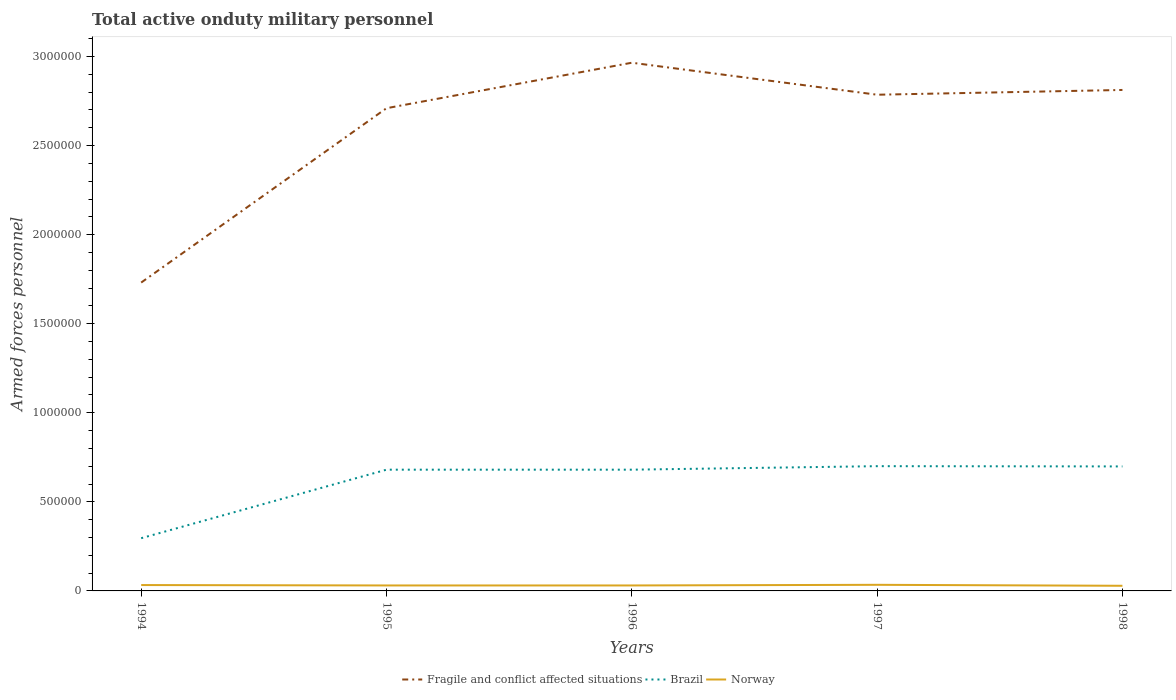Does the line corresponding to Brazil intersect with the line corresponding to Fragile and conflict affected situations?
Make the answer very short. No. Is the number of lines equal to the number of legend labels?
Ensure brevity in your answer.  Yes. Across all years, what is the maximum number of armed forces personnel in Brazil?
Ensure brevity in your answer.  2.96e+05. In which year was the number of armed forces personnel in Fragile and conflict affected situations maximum?
Your answer should be compact. 1994. What is the total number of armed forces personnel in Brazil in the graph?
Your answer should be very brief. -1.82e+04. What is the difference between the highest and the second highest number of armed forces personnel in Brazil?
Keep it short and to the point. 4.04e+05. Is the number of armed forces personnel in Brazil strictly greater than the number of armed forces personnel in Fragile and conflict affected situations over the years?
Ensure brevity in your answer.  Yes. How many lines are there?
Your answer should be very brief. 3. Are the values on the major ticks of Y-axis written in scientific E-notation?
Ensure brevity in your answer.  No. Does the graph contain any zero values?
Provide a succinct answer. No. Does the graph contain grids?
Offer a terse response. No. Where does the legend appear in the graph?
Your answer should be compact. Bottom center. What is the title of the graph?
Ensure brevity in your answer.  Total active onduty military personnel. What is the label or title of the Y-axis?
Your answer should be very brief. Armed forces personnel. What is the Armed forces personnel of Fragile and conflict affected situations in 1994?
Your response must be concise. 1.73e+06. What is the Armed forces personnel of Brazil in 1994?
Your answer should be compact. 2.96e+05. What is the Armed forces personnel in Norway in 1994?
Ensure brevity in your answer.  3.30e+04. What is the Armed forces personnel of Fragile and conflict affected situations in 1995?
Give a very brief answer. 2.71e+06. What is the Armed forces personnel of Brazil in 1995?
Offer a terse response. 6.81e+05. What is the Armed forces personnel of Norway in 1995?
Your response must be concise. 3.07e+04. What is the Armed forces personnel of Fragile and conflict affected situations in 1996?
Your answer should be very brief. 2.97e+06. What is the Armed forces personnel in Brazil in 1996?
Offer a terse response. 6.81e+05. What is the Armed forces personnel in Norway in 1996?
Your answer should be compact. 3.07e+04. What is the Armed forces personnel in Fragile and conflict affected situations in 1997?
Your response must be concise. 2.79e+06. What is the Armed forces personnel in Brazil in 1997?
Provide a succinct answer. 7.00e+05. What is the Armed forces personnel in Norway in 1997?
Keep it short and to the point. 3.43e+04. What is the Armed forces personnel in Fragile and conflict affected situations in 1998?
Your answer should be compact. 2.81e+06. What is the Armed forces personnel in Brazil in 1998?
Your answer should be compact. 6.99e+05. What is the Armed forces personnel in Norway in 1998?
Offer a very short reply. 2.89e+04. Across all years, what is the maximum Armed forces personnel in Fragile and conflict affected situations?
Provide a short and direct response. 2.97e+06. Across all years, what is the maximum Armed forces personnel of Brazil?
Offer a terse response. 7.00e+05. Across all years, what is the maximum Armed forces personnel in Norway?
Give a very brief answer. 3.43e+04. Across all years, what is the minimum Armed forces personnel in Fragile and conflict affected situations?
Provide a short and direct response. 1.73e+06. Across all years, what is the minimum Armed forces personnel of Brazil?
Keep it short and to the point. 2.96e+05. Across all years, what is the minimum Armed forces personnel in Norway?
Provide a succinct answer. 2.89e+04. What is the total Armed forces personnel in Fragile and conflict affected situations in the graph?
Provide a short and direct response. 1.30e+07. What is the total Armed forces personnel in Brazil in the graph?
Keep it short and to the point. 3.06e+06. What is the total Armed forces personnel in Norway in the graph?
Offer a very short reply. 1.58e+05. What is the difference between the Armed forces personnel in Fragile and conflict affected situations in 1994 and that in 1995?
Provide a short and direct response. -9.79e+05. What is the difference between the Armed forces personnel in Brazil in 1994 and that in 1995?
Offer a very short reply. -3.85e+05. What is the difference between the Armed forces personnel in Norway in 1994 and that in 1995?
Give a very brief answer. 2300. What is the difference between the Armed forces personnel in Fragile and conflict affected situations in 1994 and that in 1996?
Your answer should be compact. -1.23e+06. What is the difference between the Armed forces personnel of Brazil in 1994 and that in 1996?
Your response must be concise. -3.85e+05. What is the difference between the Armed forces personnel of Norway in 1994 and that in 1996?
Keep it short and to the point. 2300. What is the difference between the Armed forces personnel of Fragile and conflict affected situations in 1994 and that in 1997?
Make the answer very short. -1.05e+06. What is the difference between the Armed forces personnel of Brazil in 1994 and that in 1997?
Offer a very short reply. -4.04e+05. What is the difference between the Armed forces personnel in Norway in 1994 and that in 1997?
Your answer should be compact. -1300. What is the difference between the Armed forces personnel in Fragile and conflict affected situations in 1994 and that in 1998?
Offer a very short reply. -1.08e+06. What is the difference between the Armed forces personnel in Brazil in 1994 and that in 1998?
Your answer should be very brief. -4.03e+05. What is the difference between the Armed forces personnel of Norway in 1994 and that in 1998?
Your answer should be compact. 4130. What is the difference between the Armed forces personnel of Fragile and conflict affected situations in 1995 and that in 1996?
Give a very brief answer. -2.55e+05. What is the difference between the Armed forces personnel in Brazil in 1995 and that in 1996?
Keep it short and to the point. 0. What is the difference between the Armed forces personnel of Norway in 1995 and that in 1996?
Offer a very short reply. 0. What is the difference between the Armed forces personnel in Fragile and conflict affected situations in 1995 and that in 1997?
Provide a succinct answer. -7.57e+04. What is the difference between the Armed forces personnel of Brazil in 1995 and that in 1997?
Your response must be concise. -1.97e+04. What is the difference between the Armed forces personnel in Norway in 1995 and that in 1997?
Your answer should be compact. -3600. What is the difference between the Armed forces personnel in Fragile and conflict affected situations in 1995 and that in 1998?
Your answer should be compact. -1.02e+05. What is the difference between the Armed forces personnel of Brazil in 1995 and that in 1998?
Offer a terse response. -1.82e+04. What is the difference between the Armed forces personnel of Norway in 1995 and that in 1998?
Offer a terse response. 1830. What is the difference between the Armed forces personnel of Fragile and conflict affected situations in 1996 and that in 1997?
Provide a succinct answer. 1.80e+05. What is the difference between the Armed forces personnel of Brazil in 1996 and that in 1997?
Provide a succinct answer. -1.97e+04. What is the difference between the Armed forces personnel of Norway in 1996 and that in 1997?
Offer a very short reply. -3600. What is the difference between the Armed forces personnel in Fragile and conflict affected situations in 1996 and that in 1998?
Offer a very short reply. 1.53e+05. What is the difference between the Armed forces personnel of Brazil in 1996 and that in 1998?
Ensure brevity in your answer.  -1.82e+04. What is the difference between the Armed forces personnel of Norway in 1996 and that in 1998?
Your response must be concise. 1830. What is the difference between the Armed forces personnel in Fragile and conflict affected situations in 1997 and that in 1998?
Provide a succinct answer. -2.68e+04. What is the difference between the Armed forces personnel in Brazil in 1997 and that in 1998?
Make the answer very short. 1450. What is the difference between the Armed forces personnel of Norway in 1997 and that in 1998?
Make the answer very short. 5430. What is the difference between the Armed forces personnel in Fragile and conflict affected situations in 1994 and the Armed forces personnel in Brazil in 1995?
Your answer should be compact. 1.05e+06. What is the difference between the Armed forces personnel of Fragile and conflict affected situations in 1994 and the Armed forces personnel of Norway in 1995?
Give a very brief answer. 1.70e+06. What is the difference between the Armed forces personnel in Brazil in 1994 and the Armed forces personnel in Norway in 1995?
Your answer should be very brief. 2.65e+05. What is the difference between the Armed forces personnel in Fragile and conflict affected situations in 1994 and the Armed forces personnel in Brazil in 1996?
Offer a terse response. 1.05e+06. What is the difference between the Armed forces personnel in Fragile and conflict affected situations in 1994 and the Armed forces personnel in Norway in 1996?
Provide a short and direct response. 1.70e+06. What is the difference between the Armed forces personnel in Brazil in 1994 and the Armed forces personnel in Norway in 1996?
Your answer should be compact. 2.65e+05. What is the difference between the Armed forces personnel of Fragile and conflict affected situations in 1994 and the Armed forces personnel of Brazil in 1997?
Make the answer very short. 1.03e+06. What is the difference between the Armed forces personnel in Fragile and conflict affected situations in 1994 and the Armed forces personnel in Norway in 1997?
Make the answer very short. 1.70e+06. What is the difference between the Armed forces personnel in Brazil in 1994 and the Armed forces personnel in Norway in 1997?
Provide a succinct answer. 2.62e+05. What is the difference between the Armed forces personnel of Fragile and conflict affected situations in 1994 and the Armed forces personnel of Brazil in 1998?
Make the answer very short. 1.03e+06. What is the difference between the Armed forces personnel of Fragile and conflict affected situations in 1994 and the Armed forces personnel of Norway in 1998?
Keep it short and to the point. 1.70e+06. What is the difference between the Armed forces personnel of Brazil in 1994 and the Armed forces personnel of Norway in 1998?
Provide a short and direct response. 2.67e+05. What is the difference between the Armed forces personnel in Fragile and conflict affected situations in 1995 and the Armed forces personnel in Brazil in 1996?
Keep it short and to the point. 2.03e+06. What is the difference between the Armed forces personnel in Fragile and conflict affected situations in 1995 and the Armed forces personnel in Norway in 1996?
Ensure brevity in your answer.  2.68e+06. What is the difference between the Armed forces personnel of Brazil in 1995 and the Armed forces personnel of Norway in 1996?
Offer a very short reply. 6.50e+05. What is the difference between the Armed forces personnel of Fragile and conflict affected situations in 1995 and the Armed forces personnel of Brazil in 1997?
Give a very brief answer. 2.01e+06. What is the difference between the Armed forces personnel in Fragile and conflict affected situations in 1995 and the Armed forces personnel in Norway in 1997?
Give a very brief answer. 2.68e+06. What is the difference between the Armed forces personnel in Brazil in 1995 and the Armed forces personnel in Norway in 1997?
Ensure brevity in your answer.  6.46e+05. What is the difference between the Armed forces personnel in Fragile and conflict affected situations in 1995 and the Armed forces personnel in Brazil in 1998?
Your answer should be very brief. 2.01e+06. What is the difference between the Armed forces personnel in Fragile and conflict affected situations in 1995 and the Armed forces personnel in Norway in 1998?
Provide a short and direct response. 2.68e+06. What is the difference between the Armed forces personnel of Brazil in 1995 and the Armed forces personnel of Norway in 1998?
Your response must be concise. 6.52e+05. What is the difference between the Armed forces personnel of Fragile and conflict affected situations in 1996 and the Armed forces personnel of Brazil in 1997?
Provide a short and direct response. 2.26e+06. What is the difference between the Armed forces personnel in Fragile and conflict affected situations in 1996 and the Armed forces personnel in Norway in 1997?
Provide a succinct answer. 2.93e+06. What is the difference between the Armed forces personnel of Brazil in 1996 and the Armed forces personnel of Norway in 1997?
Keep it short and to the point. 6.46e+05. What is the difference between the Armed forces personnel in Fragile and conflict affected situations in 1996 and the Armed forces personnel in Brazil in 1998?
Give a very brief answer. 2.27e+06. What is the difference between the Armed forces personnel of Fragile and conflict affected situations in 1996 and the Armed forces personnel of Norway in 1998?
Your response must be concise. 2.94e+06. What is the difference between the Armed forces personnel in Brazil in 1996 and the Armed forces personnel in Norway in 1998?
Offer a very short reply. 6.52e+05. What is the difference between the Armed forces personnel in Fragile and conflict affected situations in 1997 and the Armed forces personnel in Brazil in 1998?
Your response must be concise. 2.09e+06. What is the difference between the Armed forces personnel of Fragile and conflict affected situations in 1997 and the Armed forces personnel of Norway in 1998?
Keep it short and to the point. 2.76e+06. What is the difference between the Armed forces personnel in Brazil in 1997 and the Armed forces personnel in Norway in 1998?
Keep it short and to the point. 6.71e+05. What is the average Armed forces personnel of Fragile and conflict affected situations per year?
Provide a succinct answer. 2.60e+06. What is the average Armed forces personnel of Brazil per year?
Provide a short and direct response. 6.11e+05. What is the average Armed forces personnel in Norway per year?
Provide a short and direct response. 3.15e+04. In the year 1994, what is the difference between the Armed forces personnel of Fragile and conflict affected situations and Armed forces personnel of Brazil?
Offer a terse response. 1.44e+06. In the year 1994, what is the difference between the Armed forces personnel in Fragile and conflict affected situations and Armed forces personnel in Norway?
Provide a short and direct response. 1.70e+06. In the year 1994, what is the difference between the Armed forces personnel of Brazil and Armed forces personnel of Norway?
Provide a succinct answer. 2.63e+05. In the year 1995, what is the difference between the Armed forces personnel in Fragile and conflict affected situations and Armed forces personnel in Brazil?
Keep it short and to the point. 2.03e+06. In the year 1995, what is the difference between the Armed forces personnel in Fragile and conflict affected situations and Armed forces personnel in Norway?
Make the answer very short. 2.68e+06. In the year 1995, what is the difference between the Armed forces personnel in Brazil and Armed forces personnel in Norway?
Offer a very short reply. 6.50e+05. In the year 1996, what is the difference between the Armed forces personnel of Fragile and conflict affected situations and Armed forces personnel of Brazil?
Provide a short and direct response. 2.28e+06. In the year 1996, what is the difference between the Armed forces personnel of Fragile and conflict affected situations and Armed forces personnel of Norway?
Your response must be concise. 2.93e+06. In the year 1996, what is the difference between the Armed forces personnel of Brazil and Armed forces personnel of Norway?
Provide a short and direct response. 6.50e+05. In the year 1997, what is the difference between the Armed forces personnel in Fragile and conflict affected situations and Armed forces personnel in Brazil?
Provide a short and direct response. 2.09e+06. In the year 1997, what is the difference between the Armed forces personnel in Fragile and conflict affected situations and Armed forces personnel in Norway?
Provide a short and direct response. 2.75e+06. In the year 1997, what is the difference between the Armed forces personnel in Brazil and Armed forces personnel in Norway?
Make the answer very short. 6.66e+05. In the year 1998, what is the difference between the Armed forces personnel of Fragile and conflict affected situations and Armed forces personnel of Brazil?
Offer a very short reply. 2.11e+06. In the year 1998, what is the difference between the Armed forces personnel of Fragile and conflict affected situations and Armed forces personnel of Norway?
Provide a short and direct response. 2.78e+06. In the year 1998, what is the difference between the Armed forces personnel of Brazil and Armed forces personnel of Norway?
Keep it short and to the point. 6.70e+05. What is the ratio of the Armed forces personnel of Fragile and conflict affected situations in 1994 to that in 1995?
Offer a terse response. 0.64. What is the ratio of the Armed forces personnel in Brazil in 1994 to that in 1995?
Provide a short and direct response. 0.43. What is the ratio of the Armed forces personnel in Norway in 1994 to that in 1995?
Give a very brief answer. 1.07. What is the ratio of the Armed forces personnel of Fragile and conflict affected situations in 1994 to that in 1996?
Offer a terse response. 0.58. What is the ratio of the Armed forces personnel in Brazil in 1994 to that in 1996?
Offer a terse response. 0.43. What is the ratio of the Armed forces personnel in Norway in 1994 to that in 1996?
Make the answer very short. 1.07. What is the ratio of the Armed forces personnel of Fragile and conflict affected situations in 1994 to that in 1997?
Give a very brief answer. 0.62. What is the ratio of the Armed forces personnel in Brazil in 1994 to that in 1997?
Your response must be concise. 0.42. What is the ratio of the Armed forces personnel in Norway in 1994 to that in 1997?
Your response must be concise. 0.96. What is the ratio of the Armed forces personnel of Fragile and conflict affected situations in 1994 to that in 1998?
Your answer should be compact. 0.62. What is the ratio of the Armed forces personnel of Brazil in 1994 to that in 1998?
Give a very brief answer. 0.42. What is the ratio of the Armed forces personnel of Norway in 1994 to that in 1998?
Ensure brevity in your answer.  1.14. What is the ratio of the Armed forces personnel of Fragile and conflict affected situations in 1995 to that in 1996?
Give a very brief answer. 0.91. What is the ratio of the Armed forces personnel of Brazil in 1995 to that in 1996?
Offer a very short reply. 1. What is the ratio of the Armed forces personnel of Fragile and conflict affected situations in 1995 to that in 1997?
Offer a terse response. 0.97. What is the ratio of the Armed forces personnel of Brazil in 1995 to that in 1997?
Provide a succinct answer. 0.97. What is the ratio of the Armed forces personnel in Norway in 1995 to that in 1997?
Give a very brief answer. 0.9. What is the ratio of the Armed forces personnel of Fragile and conflict affected situations in 1995 to that in 1998?
Your answer should be compact. 0.96. What is the ratio of the Armed forces personnel in Brazil in 1995 to that in 1998?
Provide a short and direct response. 0.97. What is the ratio of the Armed forces personnel of Norway in 1995 to that in 1998?
Make the answer very short. 1.06. What is the ratio of the Armed forces personnel of Fragile and conflict affected situations in 1996 to that in 1997?
Offer a very short reply. 1.06. What is the ratio of the Armed forces personnel of Brazil in 1996 to that in 1997?
Your answer should be very brief. 0.97. What is the ratio of the Armed forces personnel in Norway in 1996 to that in 1997?
Your response must be concise. 0.9. What is the ratio of the Armed forces personnel of Fragile and conflict affected situations in 1996 to that in 1998?
Your response must be concise. 1.05. What is the ratio of the Armed forces personnel in Brazil in 1996 to that in 1998?
Provide a succinct answer. 0.97. What is the ratio of the Armed forces personnel of Norway in 1996 to that in 1998?
Provide a succinct answer. 1.06. What is the ratio of the Armed forces personnel in Fragile and conflict affected situations in 1997 to that in 1998?
Provide a succinct answer. 0.99. What is the ratio of the Armed forces personnel of Brazil in 1997 to that in 1998?
Offer a terse response. 1. What is the ratio of the Armed forces personnel in Norway in 1997 to that in 1998?
Provide a succinct answer. 1.19. What is the difference between the highest and the second highest Armed forces personnel in Fragile and conflict affected situations?
Give a very brief answer. 1.53e+05. What is the difference between the highest and the second highest Armed forces personnel of Brazil?
Provide a succinct answer. 1450. What is the difference between the highest and the second highest Armed forces personnel of Norway?
Give a very brief answer. 1300. What is the difference between the highest and the lowest Armed forces personnel of Fragile and conflict affected situations?
Keep it short and to the point. 1.23e+06. What is the difference between the highest and the lowest Armed forces personnel in Brazil?
Provide a succinct answer. 4.04e+05. What is the difference between the highest and the lowest Armed forces personnel of Norway?
Ensure brevity in your answer.  5430. 